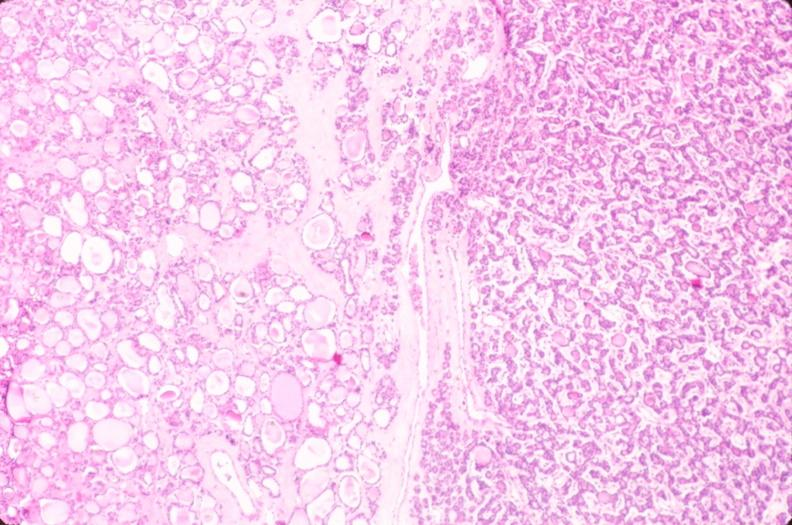s chest and abdomen slide present?
Answer the question using a single word or phrase. No 